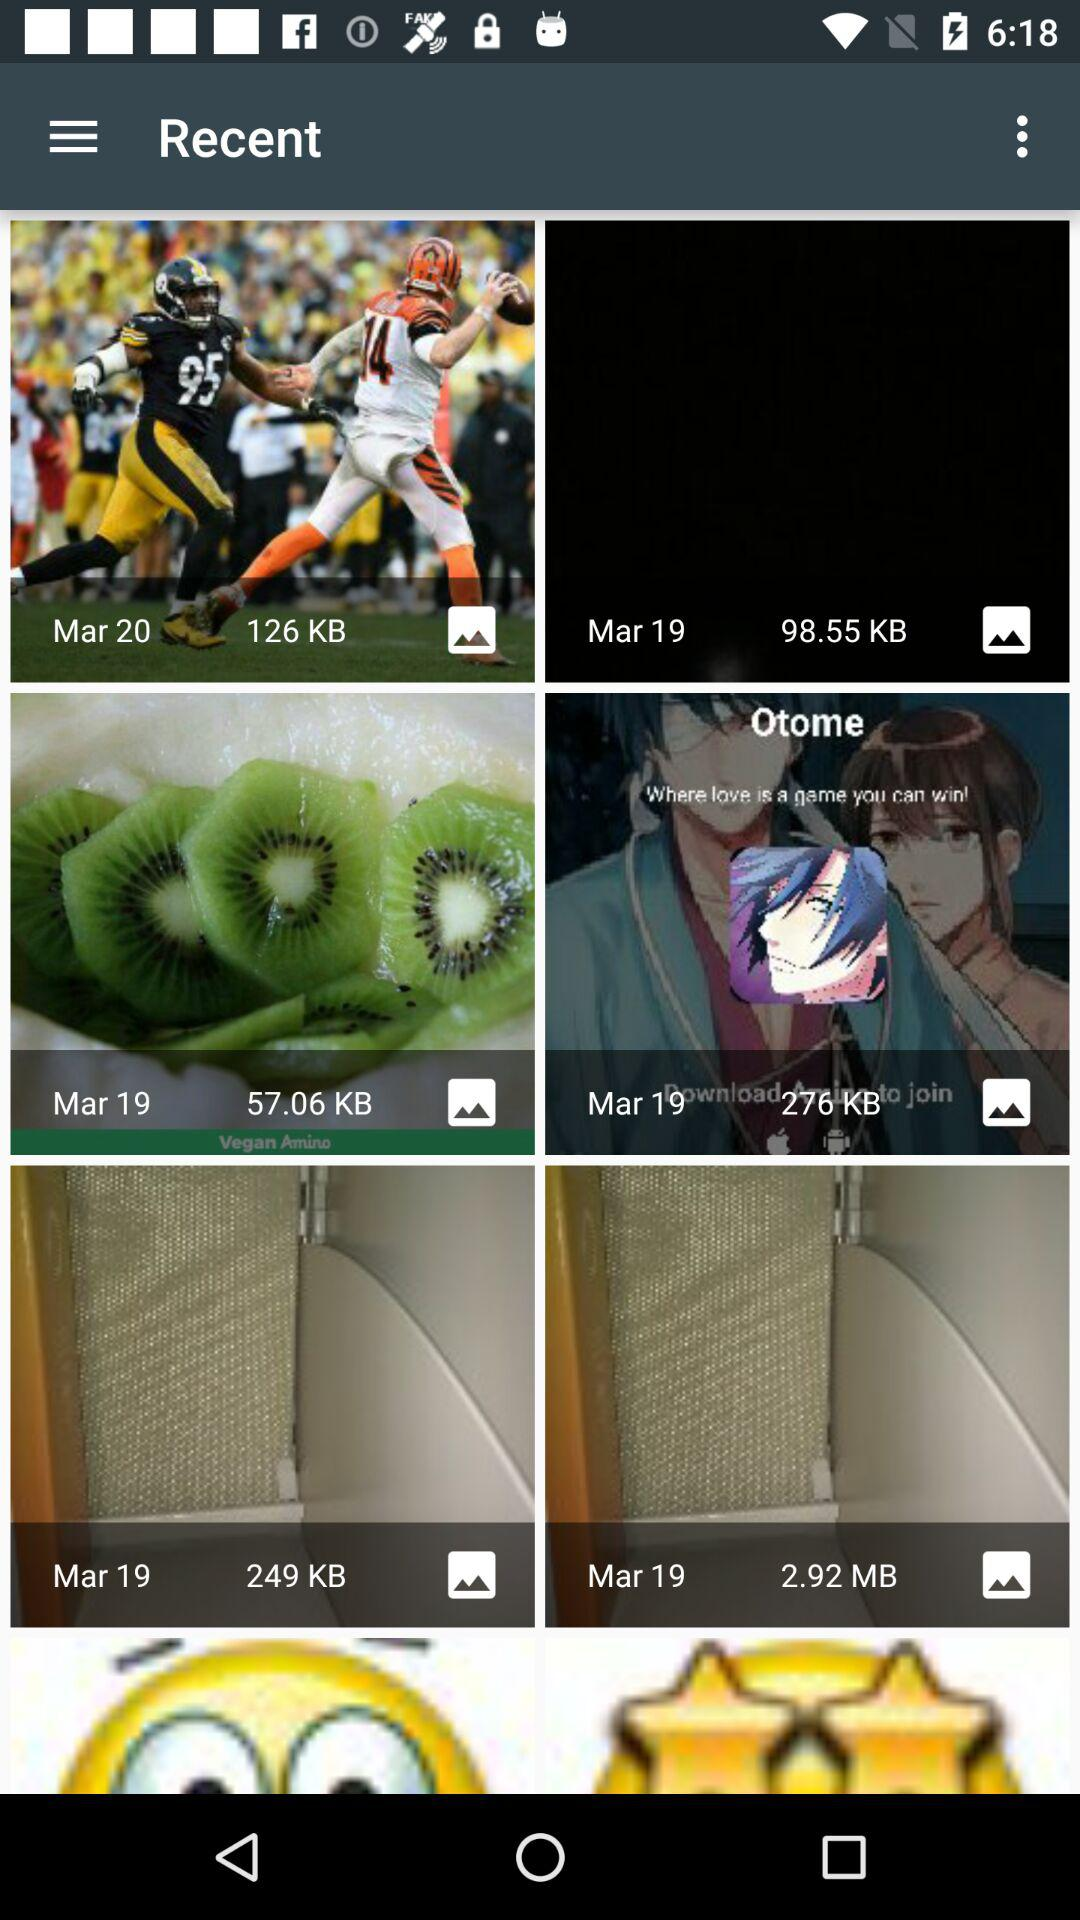What is the size of the image dated Mar 20? The size is 126 KB. 